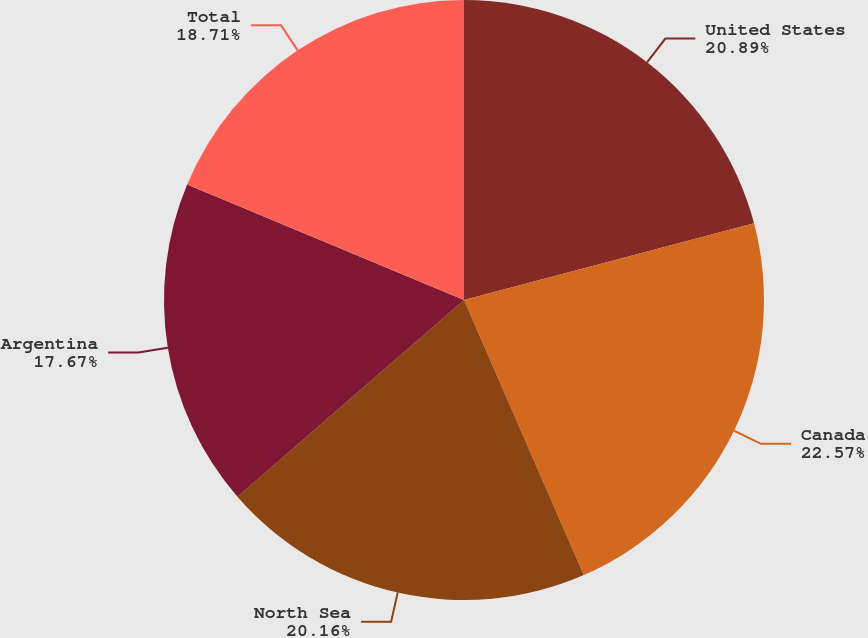<chart> <loc_0><loc_0><loc_500><loc_500><pie_chart><fcel>United States<fcel>Canada<fcel>North Sea<fcel>Argentina<fcel>Total<nl><fcel>20.89%<fcel>22.58%<fcel>20.16%<fcel>17.67%<fcel>18.71%<nl></chart> 